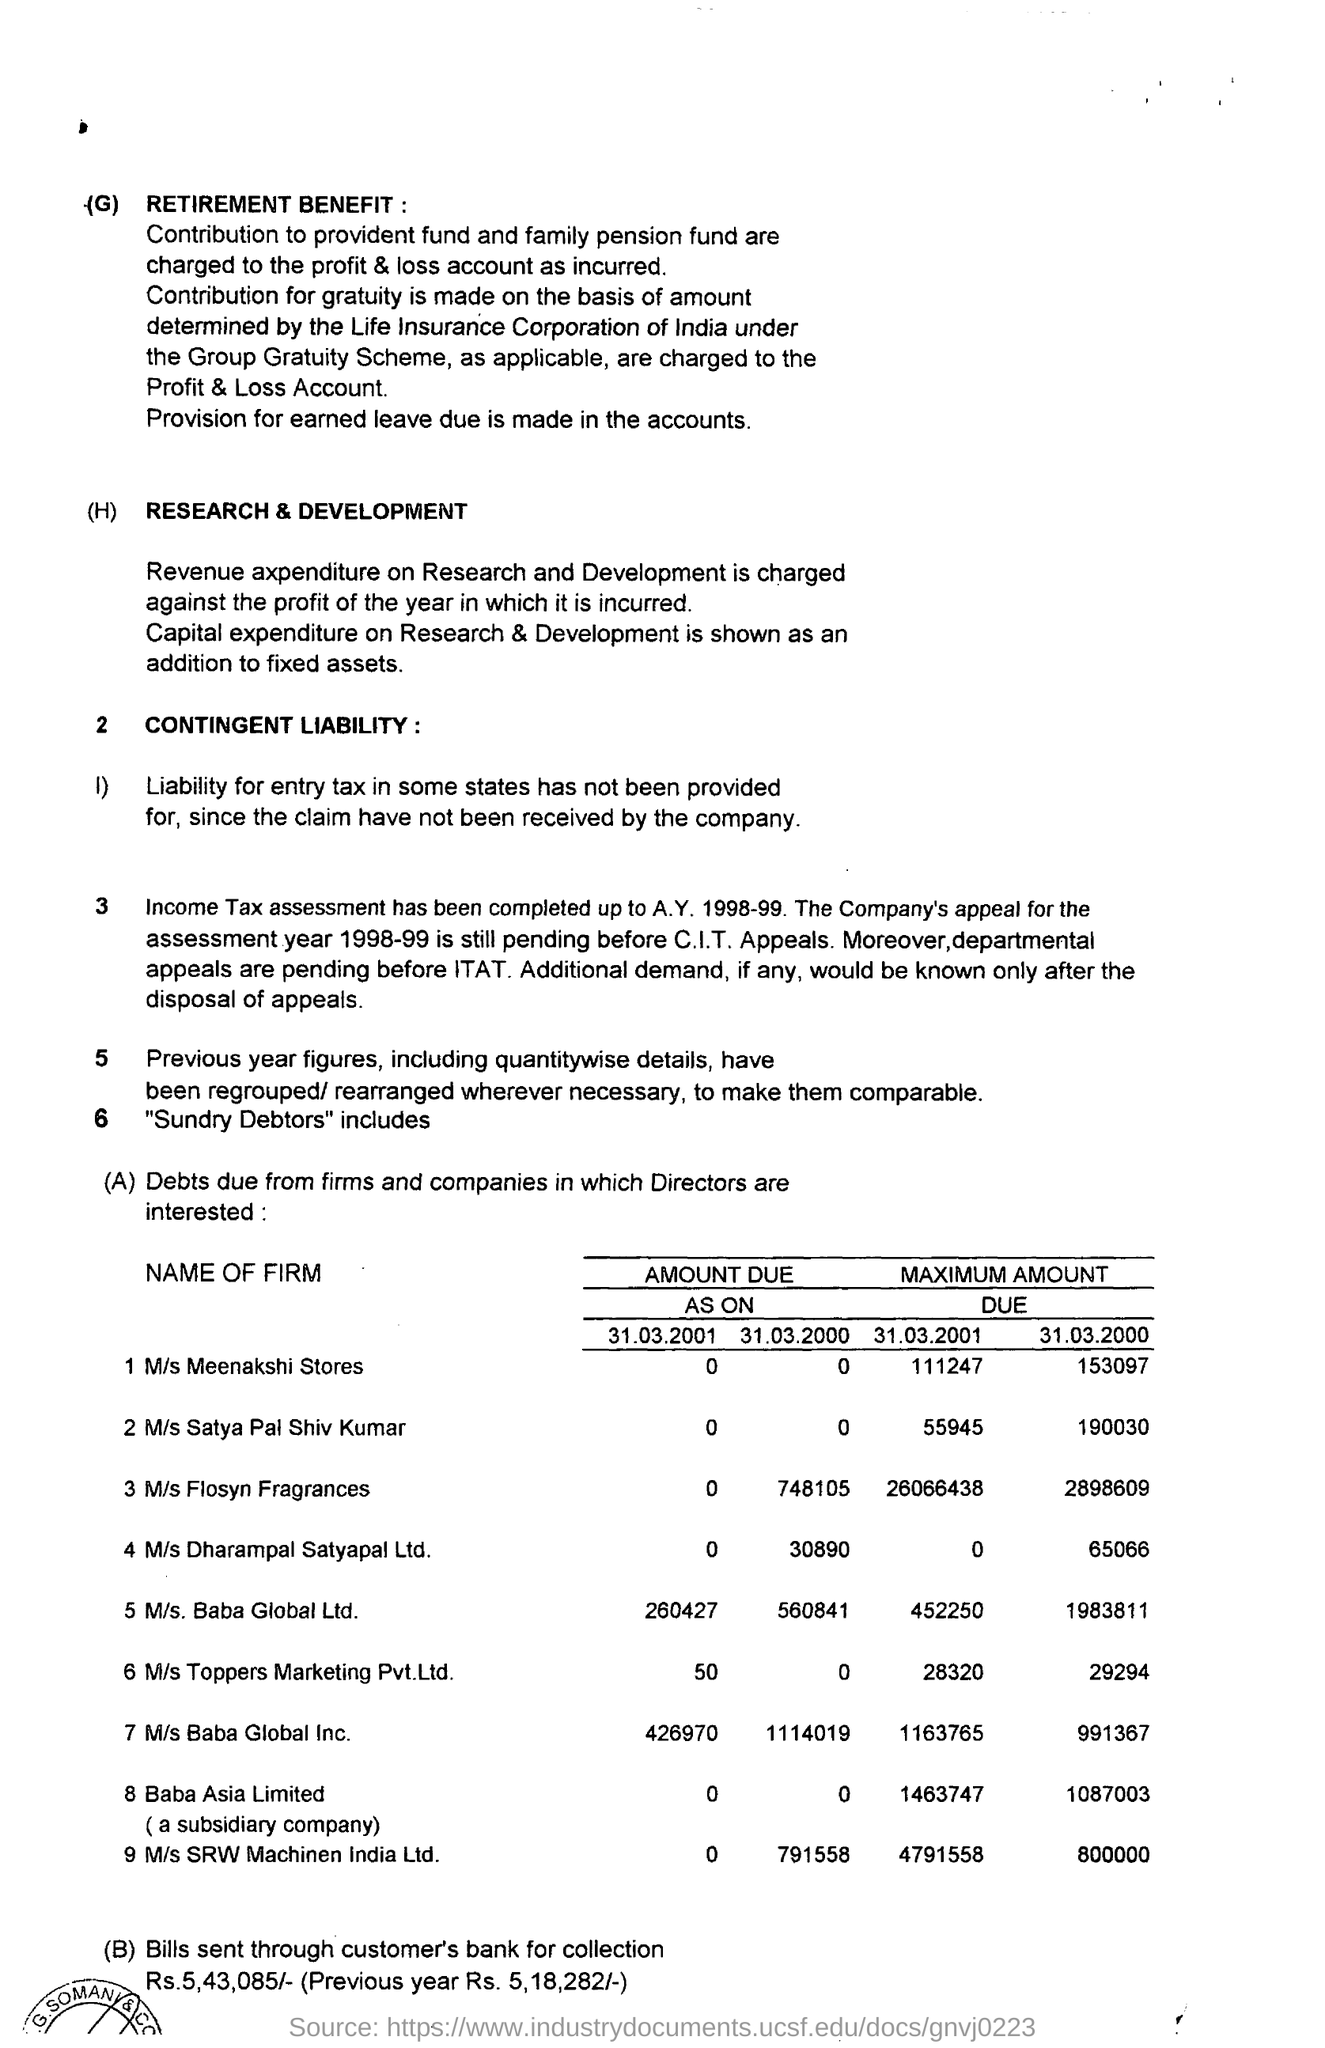What is the Maximum Amount Due for M/s Meenakshi Stores on 31.03.2001?
Your answer should be compact. 111247. What is the Maximum Amount Due for M/s Meenakshi Stores on 31.03.2000?
Make the answer very short. 153097. What is the Maximum Amount Due for M/s Baba Global ltd on 31.03.2001?
Keep it short and to the point. 452250. What is the Maximum Amount Due for M/s Baba Global ltd on 31.03.2000?
Provide a succinct answer. 1983811. What is the Maximum Amount Due for M/s Baba Global lnc. on 31.03.2001?
Ensure brevity in your answer.  1163765. What is the Maximum Amount Due for M/s Baba Global lnc. on 31.03.2000?
Provide a succinct answer. 991367. What is the Maximum Amount Due for M/s Flosyn Fragrances on 31.03.2001?
Your response must be concise. 26066438. What is the Maximum Amount Due for M/s Flosyn Fragrances on 31.03.2000?
Ensure brevity in your answer.  2898609. What is the Maximum Amount Due for Baba Asia Ltd on 31.03.2001?
Ensure brevity in your answer.  1463747. What is the Maximum Amount Due for Baba Asia Ltd on 31.03.2000?
Your answer should be compact. 1087003. 